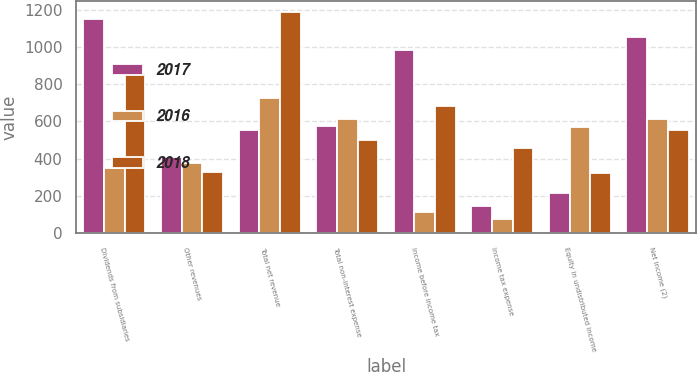Convert chart. <chart><loc_0><loc_0><loc_500><loc_500><stacked_bar_chart><ecel><fcel>Dividends from subsidiaries<fcel>Other revenues<fcel>Total net revenue<fcel>Total non-interest expense<fcel>Income before income tax<fcel>Income tax expense<fcel>Equity in undistributed income<fcel>Net income (2)<nl><fcel>2017<fcel>1150<fcel>410<fcel>552<fcel>575<fcel>985<fcel>149<fcel>216<fcel>1052<nl><fcel>2016<fcel>350<fcel>377<fcel>727<fcel>611<fcel>116<fcel>75<fcel>573<fcel>614<nl><fcel>2018<fcel>858<fcel>328<fcel>1186<fcel>501<fcel>685<fcel>456<fcel>323<fcel>552<nl></chart> 